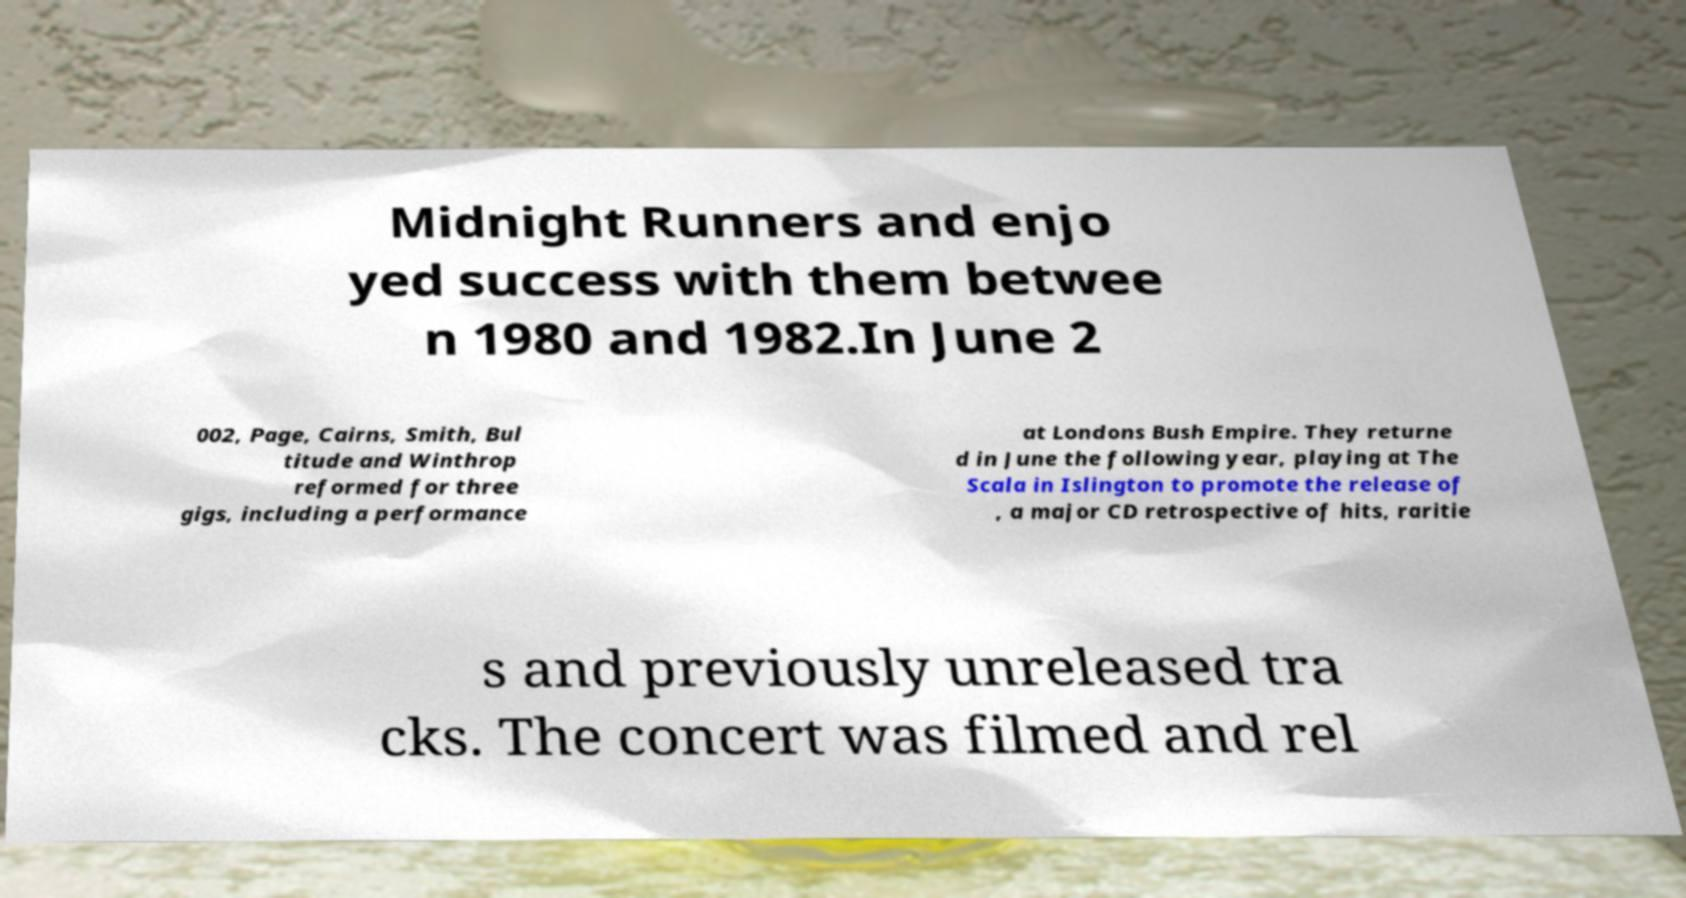Could you extract and type out the text from this image? Midnight Runners and enjo yed success with them betwee n 1980 and 1982.In June 2 002, Page, Cairns, Smith, Bul titude and Winthrop reformed for three gigs, including a performance at Londons Bush Empire. They returne d in June the following year, playing at The Scala in Islington to promote the release of , a major CD retrospective of hits, raritie s and previously unreleased tra cks. The concert was filmed and rel 